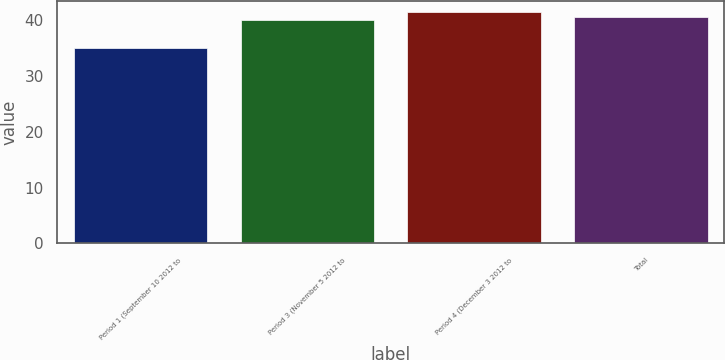<chart> <loc_0><loc_0><loc_500><loc_500><bar_chart><fcel>Period 1 (September 10 2012 to<fcel>Period 3 (November 5 2012 to<fcel>Period 4 (December 3 2012 to<fcel>Total<nl><fcel>35.03<fcel>40.05<fcel>41.44<fcel>40.69<nl></chart> 